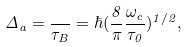Convert formula to latex. <formula><loc_0><loc_0><loc_500><loc_500>\Delta _ { a } = \frac { } { \tau _ { B } } = \hbar { ( } \frac { 8 } { \pi } \frac { \omega _ { c } } { \tau _ { 0 } } ) ^ { 1 / 2 } ,</formula> 